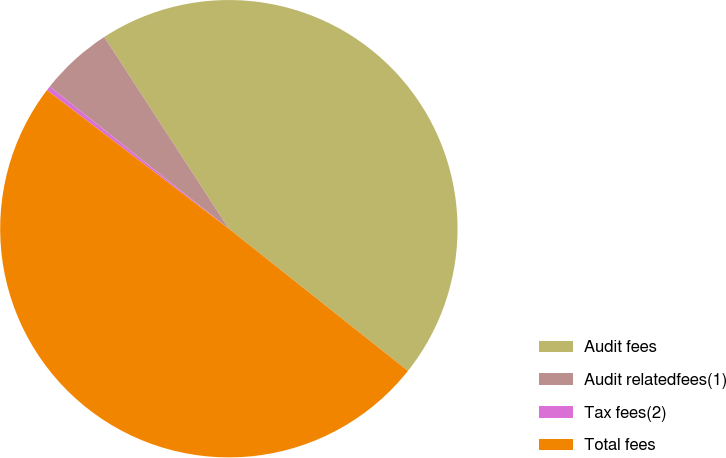<chart> <loc_0><loc_0><loc_500><loc_500><pie_chart><fcel>Audit fees<fcel>Audit relatedfees(1)<fcel>Tax fees(2)<fcel>Total fees<nl><fcel>44.85%<fcel>5.15%<fcel>0.32%<fcel>49.68%<nl></chart> 